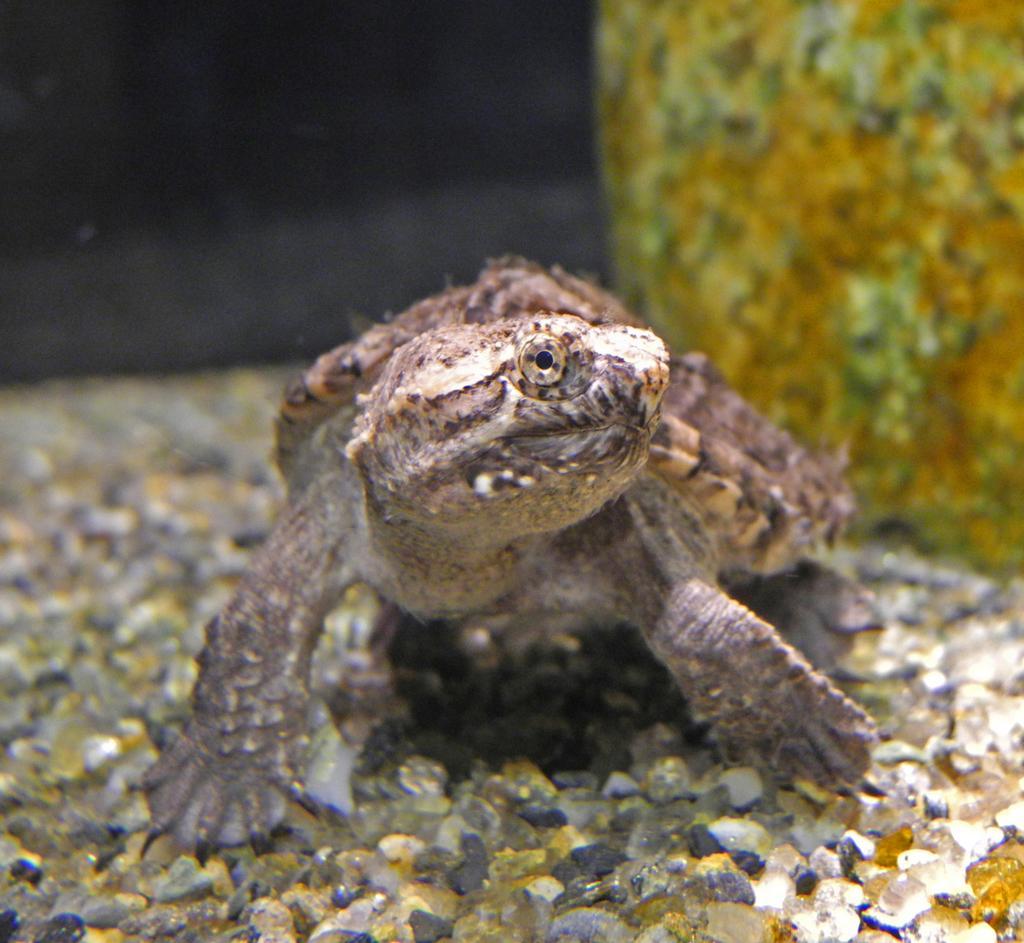Describe this image in one or two sentences. In this picture I can see a turtle in front which is on the stones. I see that it is a bit dark in the background and on the right side of this picture I can see yellow color thing. 